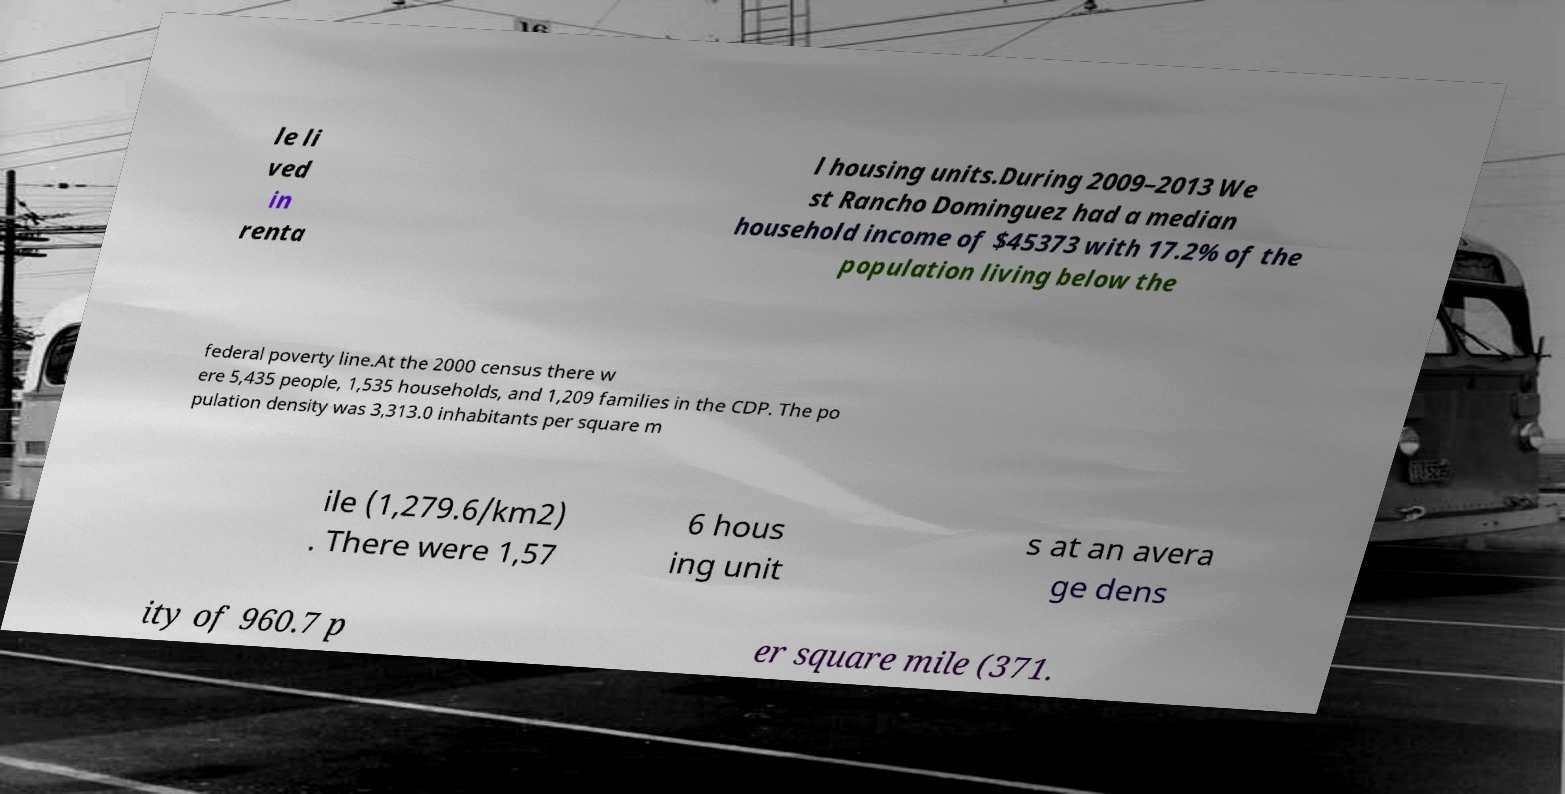I need the written content from this picture converted into text. Can you do that? le li ved in renta l housing units.During 2009–2013 We st Rancho Dominguez had a median household income of $45373 with 17.2% of the population living below the federal poverty line.At the 2000 census there w ere 5,435 people, 1,535 households, and 1,209 families in the CDP. The po pulation density was 3,313.0 inhabitants per square m ile (1,279.6/km2) . There were 1,57 6 hous ing unit s at an avera ge dens ity of 960.7 p er square mile (371. 